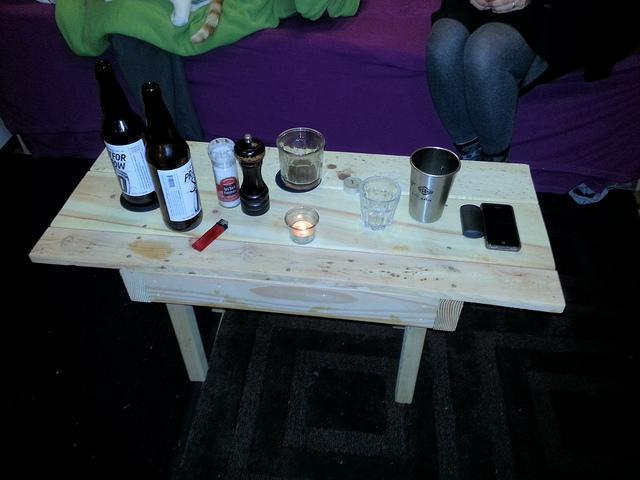How many people can you see?
Give a very brief answer. 2. How many cups are visible?
Give a very brief answer. 2. How many bottles can you see?
Give a very brief answer. 2. 